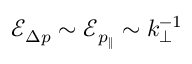Convert formula to latex. <formula><loc_0><loc_0><loc_500><loc_500>\mathcal { E } _ { \Delta p } \sim \mathcal { E } _ { p _ { \| } } \sim k _ { \perp } ^ { - 1 }</formula> 